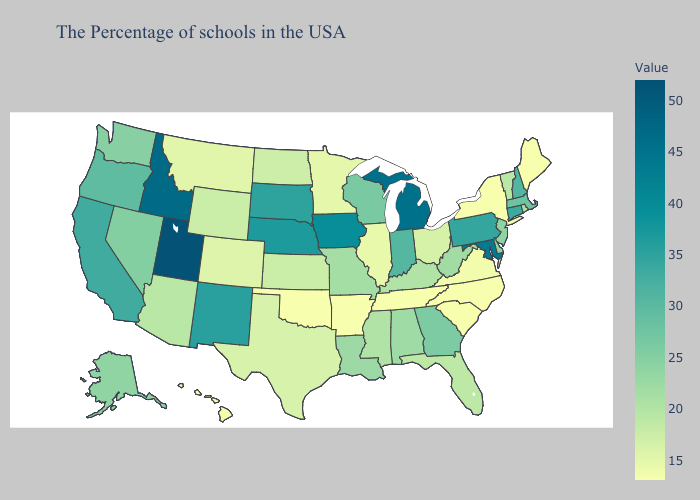Does New York have the highest value in the USA?
Be succinct. No. Among the states that border Kentucky , does Tennessee have the highest value?
Answer briefly. No. Which states have the lowest value in the USA?
Keep it brief. Maine, New York, North Carolina, South Carolina, Tennessee, Arkansas, Oklahoma, Hawaii. Among the states that border Wyoming , does Montana have the lowest value?
Answer briefly. Yes. Does Utah have the highest value in the USA?
Concise answer only. Yes. Among the states that border North Carolina , which have the highest value?
Answer briefly. Georgia. Does Delaware have the lowest value in the South?
Short answer required. No. Does Kansas have the lowest value in the USA?
Concise answer only. No. 